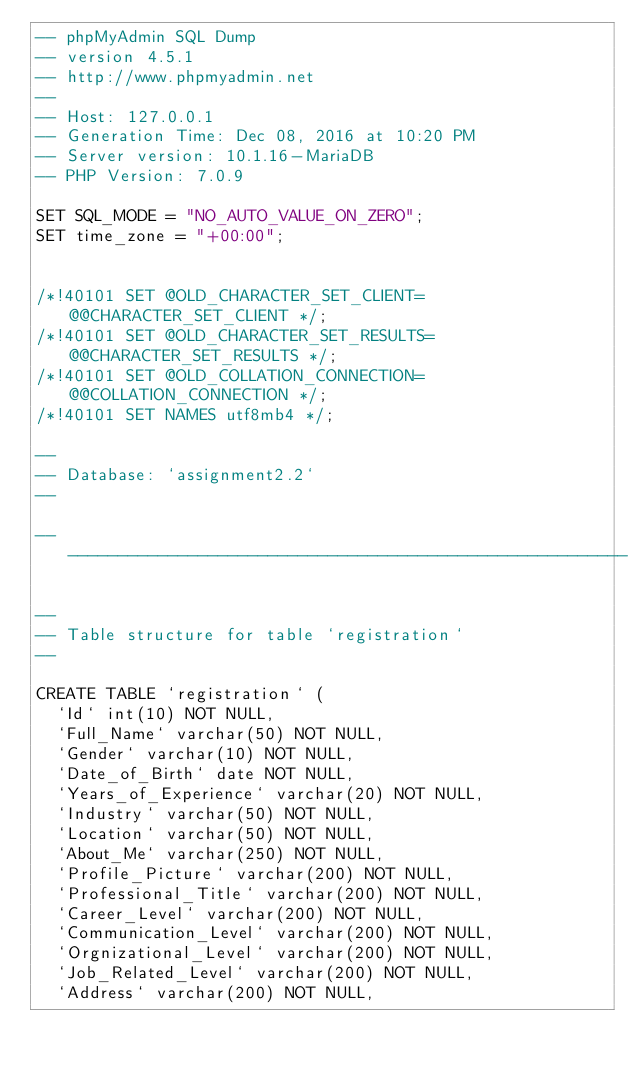<code> <loc_0><loc_0><loc_500><loc_500><_SQL_>-- phpMyAdmin SQL Dump
-- version 4.5.1
-- http://www.phpmyadmin.net
--
-- Host: 127.0.0.1
-- Generation Time: Dec 08, 2016 at 10:20 PM
-- Server version: 10.1.16-MariaDB
-- PHP Version: 7.0.9

SET SQL_MODE = "NO_AUTO_VALUE_ON_ZERO";
SET time_zone = "+00:00";


/*!40101 SET @OLD_CHARACTER_SET_CLIENT=@@CHARACTER_SET_CLIENT */;
/*!40101 SET @OLD_CHARACTER_SET_RESULTS=@@CHARACTER_SET_RESULTS */;
/*!40101 SET @OLD_COLLATION_CONNECTION=@@COLLATION_CONNECTION */;
/*!40101 SET NAMES utf8mb4 */;

--
-- Database: `assignment2.2`
--

-- --------------------------------------------------------

--
-- Table structure for table `registration`
--

CREATE TABLE `registration` (
  `Id` int(10) NOT NULL,
  `Full_Name` varchar(50) NOT NULL,
  `Gender` varchar(10) NOT NULL,
  `Date_of_Birth` date NOT NULL,
  `Years_of_Experience` varchar(20) NOT NULL,
  `Industry` varchar(50) NOT NULL,
  `Location` varchar(50) NOT NULL,
  `About_Me` varchar(250) NOT NULL,
  `Profile_Picture` varchar(200) NOT NULL,
  `Professional_Title` varchar(200) NOT NULL,
  `Career_Level` varchar(200) NOT NULL,
  `Communication_Level` varchar(200) NOT NULL,
  `Orgnizational_Level` varchar(200) NOT NULL,
  `Job_Related_Level` varchar(200) NOT NULL,
  `Address` varchar(200) NOT NULL,</code> 